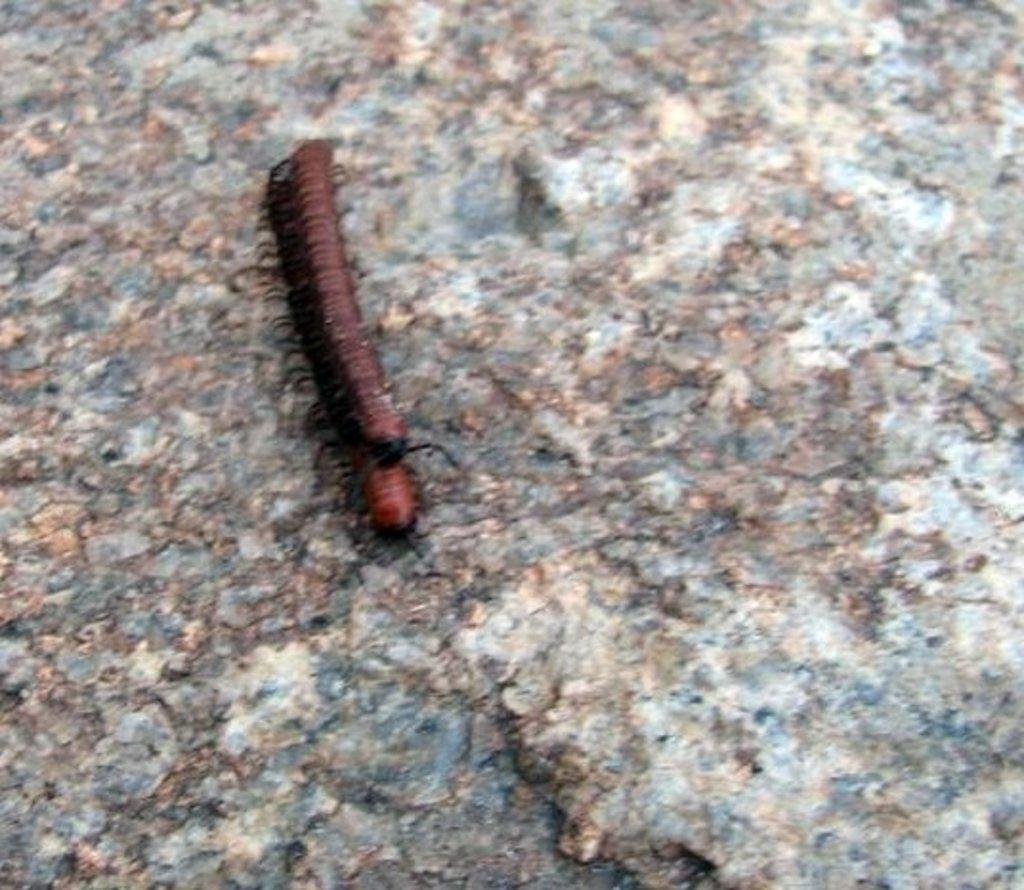What is the main subject of the picture? The main subject of the picture is a millipede. Where is the millipede located in the image? The millipede is on a rock. What color is the millipede? The millipede is red in color. What type of wax is being used to fuel the engine in the image? There is no engine or wax present in the image; it features a red millipede on a rock. 